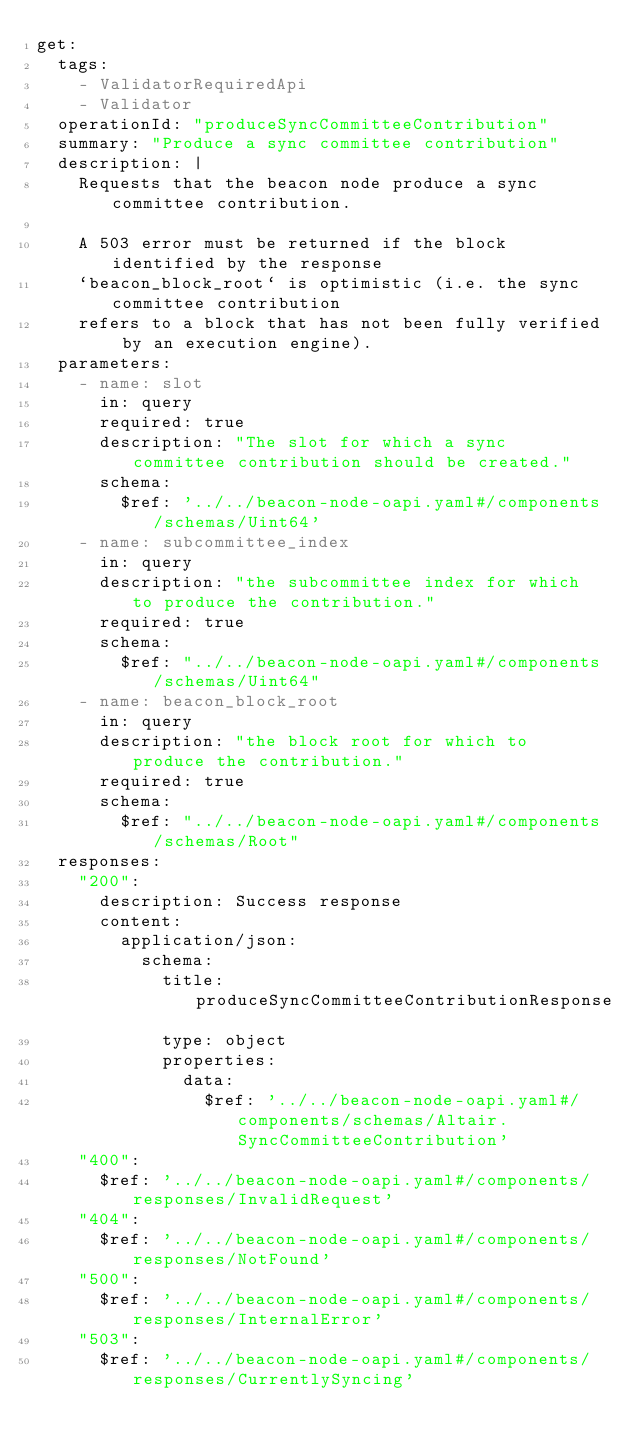Convert code to text. <code><loc_0><loc_0><loc_500><loc_500><_YAML_>get:
  tags:
    - ValidatorRequiredApi
    - Validator
  operationId: "produceSyncCommitteeContribution"
  summary: "Produce a sync committee contribution"
  description: |
    Requests that the beacon node produce a sync committee contribution.

    A 503 error must be returned if the block identified by the response
    `beacon_block_root` is optimistic (i.e. the sync committee contribution
    refers to a block that has not been fully verified by an execution engine).
  parameters:
    - name: slot
      in: query
      required: true
      description: "The slot for which a sync committee contribution should be created."
      schema:
        $ref: '../../beacon-node-oapi.yaml#/components/schemas/Uint64'
    - name: subcommittee_index
      in: query
      description: "the subcommittee index for which to produce the contribution."
      required: true
      schema:
        $ref: "../../beacon-node-oapi.yaml#/components/schemas/Uint64"
    - name: beacon_block_root
      in: query
      description: "the block root for which to produce the contribution."
      required: true
      schema:
        $ref: "../../beacon-node-oapi.yaml#/components/schemas/Root"
  responses:
    "200":
      description: Success response
      content:
        application/json:
          schema:
            title: produceSyncCommitteeContributionResponse
            type: object
            properties:
              data:
                $ref: '../../beacon-node-oapi.yaml#/components/schemas/Altair.SyncCommitteeContribution'
    "400":
      $ref: '../../beacon-node-oapi.yaml#/components/responses/InvalidRequest'
    "404":
      $ref: '../../beacon-node-oapi.yaml#/components/responses/NotFound'
    "500":
      $ref: '../../beacon-node-oapi.yaml#/components/responses/InternalError'
    "503":
      $ref: '../../beacon-node-oapi.yaml#/components/responses/CurrentlySyncing'
</code> 